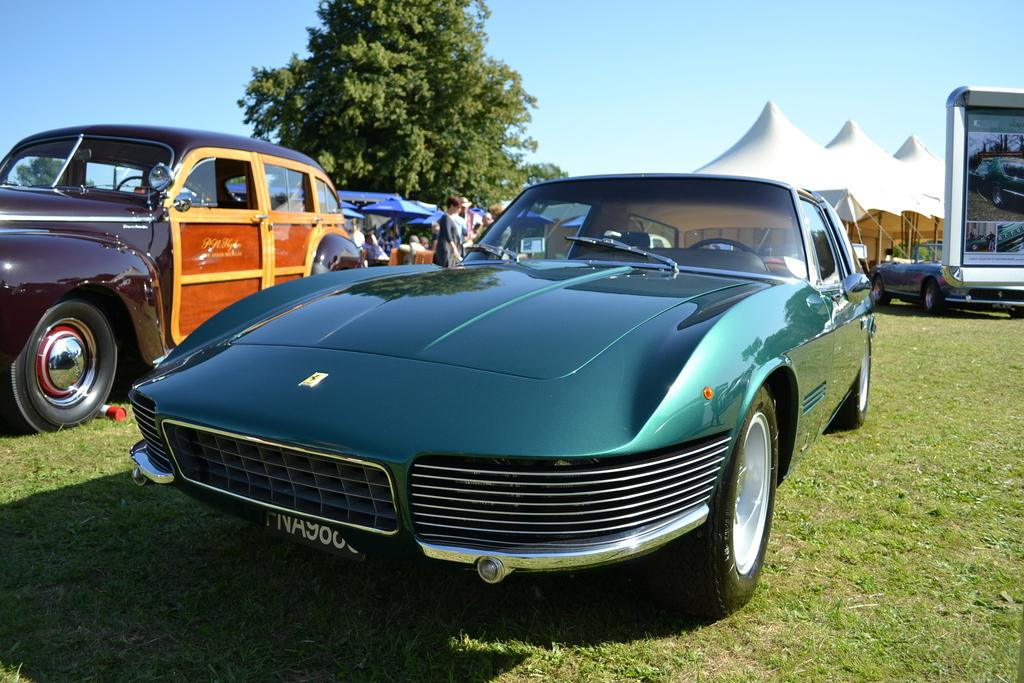What is the main subject in the center of the image? There are cars in the center of the image. What can be seen in the background of the image? There are tents and people visible in the background of the image. Where is the tree located in the image? The tree is on the left side of the image. What is visible in the background of the image besides the tents and people? The sky is visible in the background of the image. Can you describe the bedroom in the image? There is no bedroom present in the image; it features cars, tents, people, a tree, and the sky. How many friends are visible in the image? There is no specific mention of friends in the image; it only mentions people in the background. 